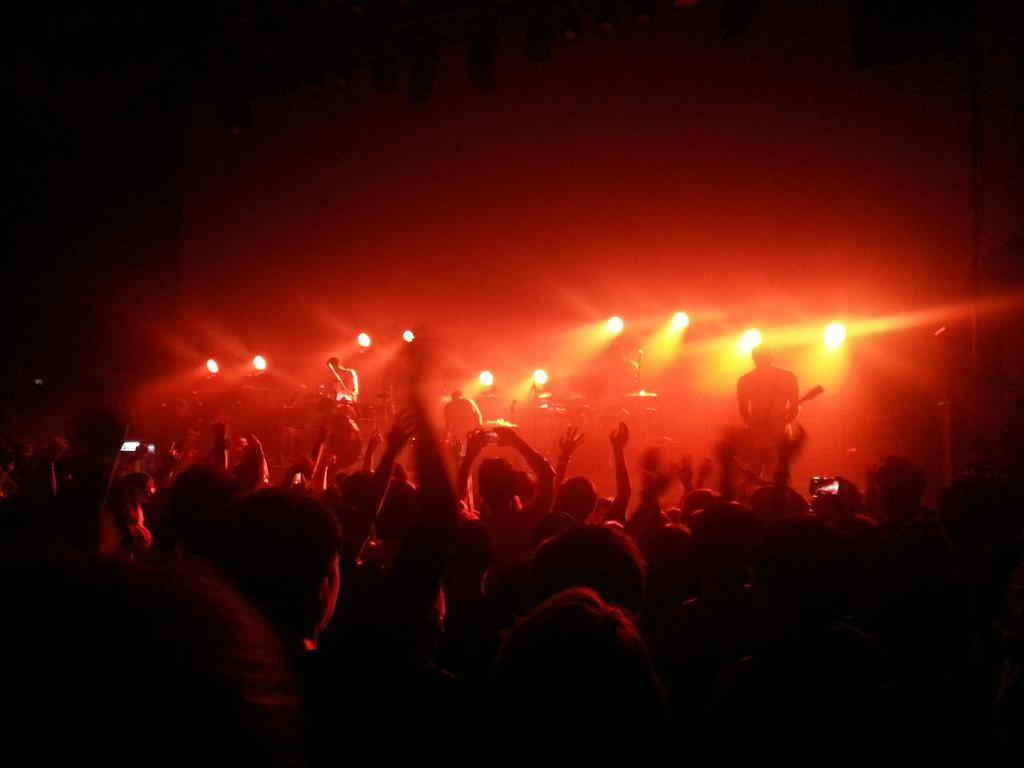How many people are in the image? There is a group of persons in the image, but the exact number is not specified. What can be seen in addition to the people in the image? There are lights visible in the image. What are the people in the image doing? There are people playing musical instruments in the image. What is the color of the background in the image? The background of the image is dark. What type of yoke is being used by the people in the image? There is no yoke present in the image; the people are playing musical instruments. What stage of development is the unit in the image? There is no unit present in the image; it features a group of people playing musical instruments against a dark background. 